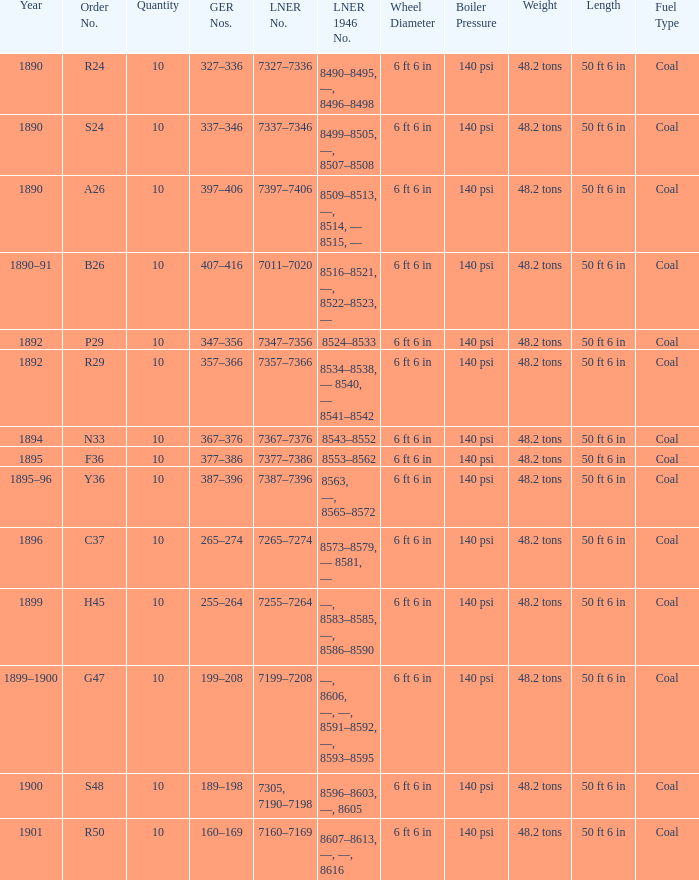What is order S24's LNER 1946 number? 8499–8505, —, 8507–8508. 